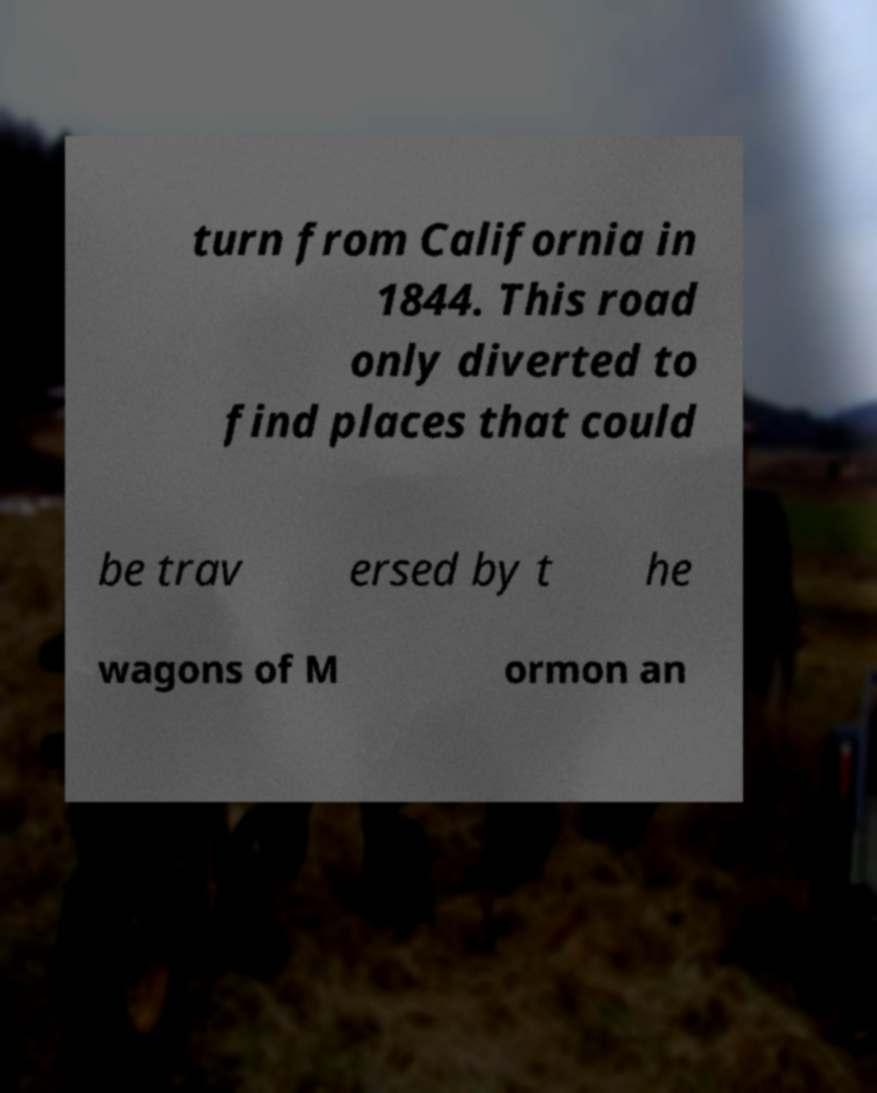What messages or text are displayed in this image? I need them in a readable, typed format. turn from California in 1844. This road only diverted to find places that could be trav ersed by t he wagons of M ormon an 